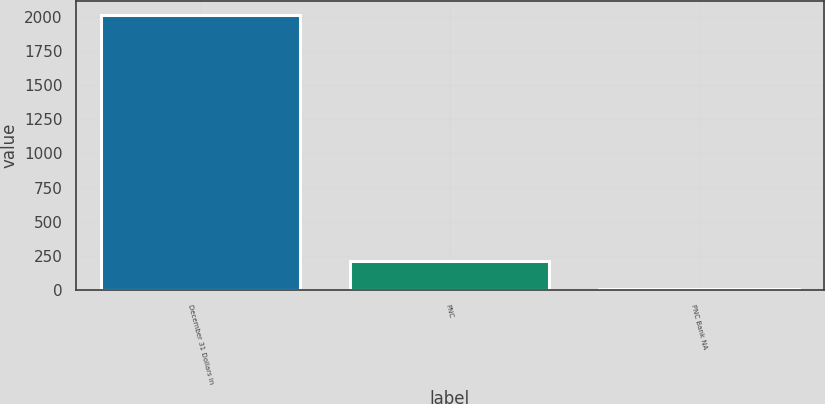<chart> <loc_0><loc_0><loc_500><loc_500><bar_chart><fcel>December 31 Dollars in<fcel>PNC<fcel>PNC Bank NA<nl><fcel>2012<fcel>211.37<fcel>11.3<nl></chart> 